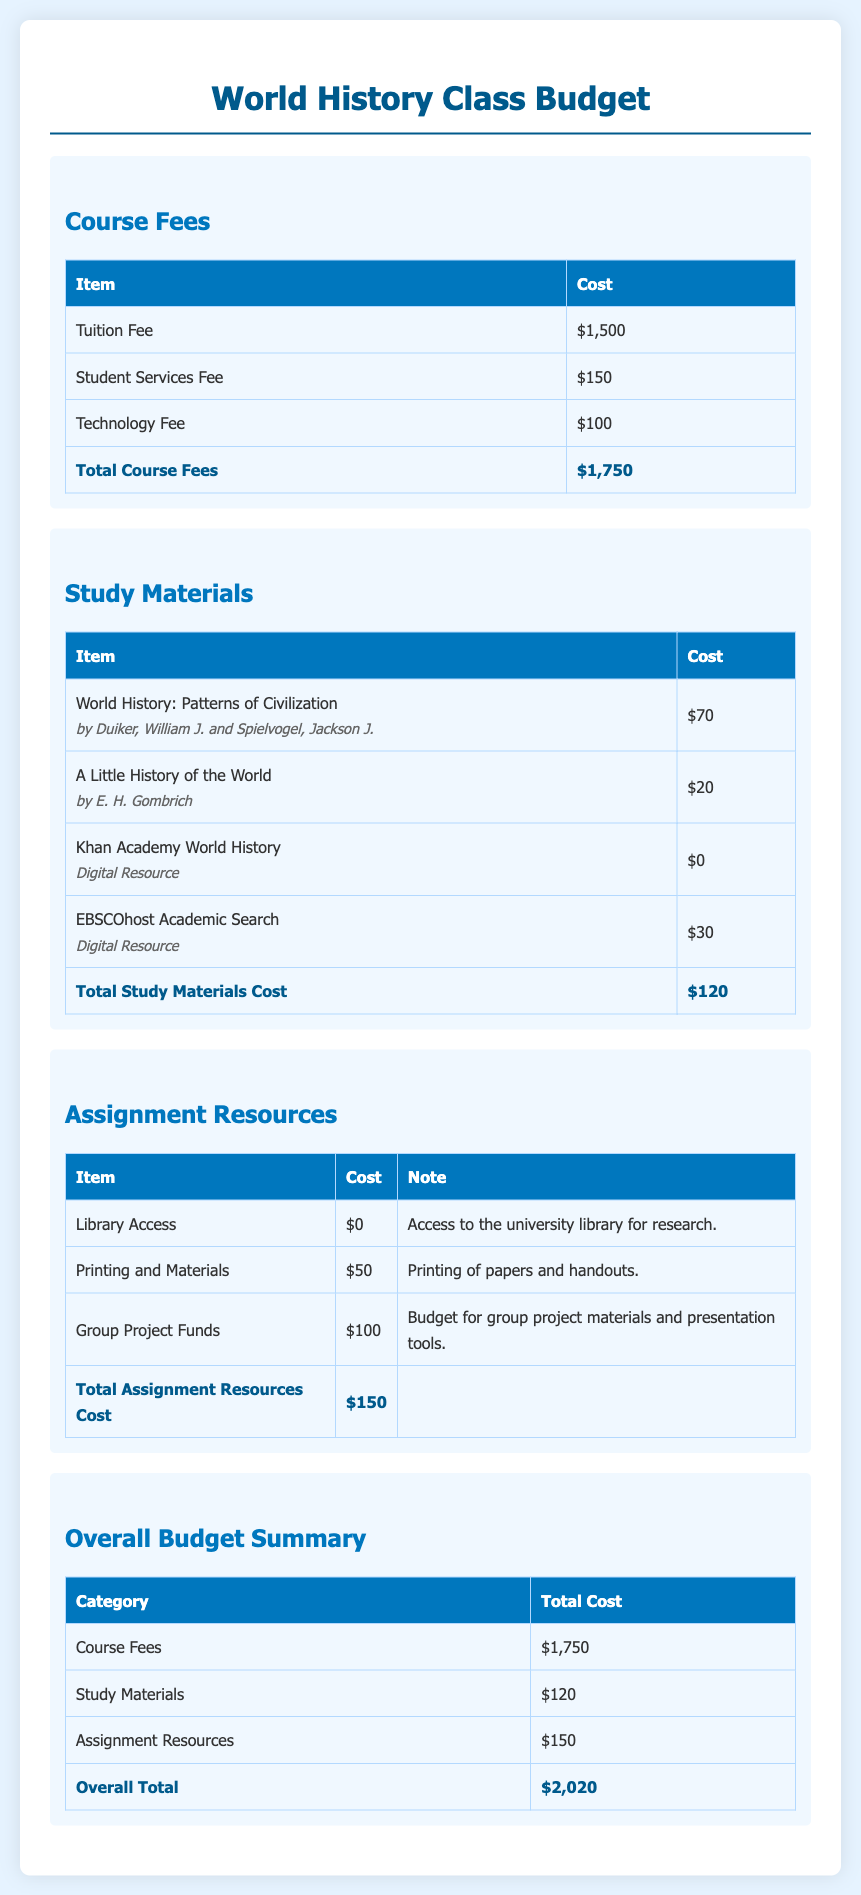What is the tuition fee for the World History class? The tuition fee is listed in the course fees section of the document as $1,500.
Answer: $1,500 What are the total costs for study materials? The total study materials cost is shown at the end of the study materials section, which adds up to $120.
Answer: $120 How much is allocated for group project funds? The budget for group project funds is provided in the assignment resources section as $100.
Answer: $100 What is the total course fees? The total course fees is the sum of all fees listed, which amounts to $1,750.
Answer: $1,750 What is the overall budget total for the World History class? The overall budget total is stated in the overall budget summary section as $2,020.
Answer: $2,020 How much is the cost for printing and materials? The cost for printing and materials is specified in the assignment resources section as $50.
Answer: $50 What digital resource has no cost associated with it? The document lists Khan Academy World History as a digital resource with a cost of $0.
Answer: $0 How many items are listed under study materials? There are four items listed under study materials in the document.
Answer: Four items What is the total amount allocated for assignment resources? The total assignment resources cost is summarized as $150 in the assignment resources section.
Answer: $150 